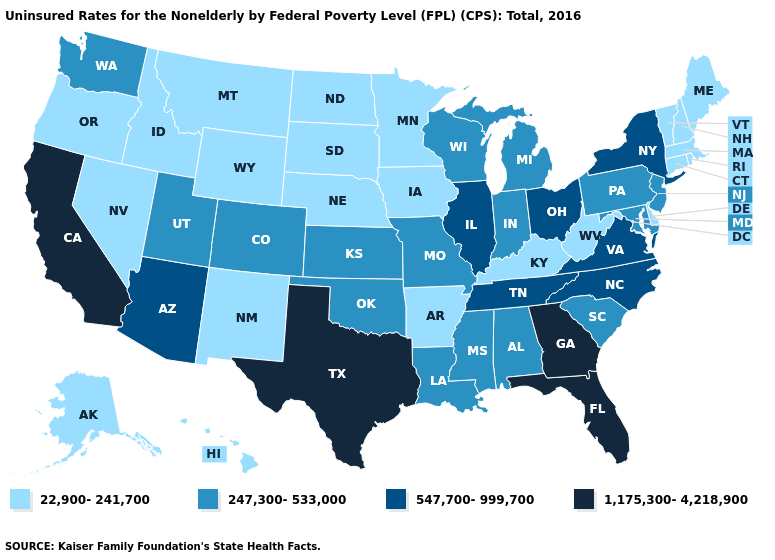Does Colorado have the lowest value in the USA?
Keep it brief. No. What is the value of Connecticut?
Write a very short answer. 22,900-241,700. What is the value of North Dakota?
Give a very brief answer. 22,900-241,700. What is the value of Pennsylvania?
Short answer required. 247,300-533,000. Name the states that have a value in the range 547,700-999,700?
Quick response, please. Arizona, Illinois, New York, North Carolina, Ohio, Tennessee, Virginia. What is the value of Rhode Island?
Quick response, please. 22,900-241,700. Name the states that have a value in the range 22,900-241,700?
Quick response, please. Alaska, Arkansas, Connecticut, Delaware, Hawaii, Idaho, Iowa, Kentucky, Maine, Massachusetts, Minnesota, Montana, Nebraska, Nevada, New Hampshire, New Mexico, North Dakota, Oregon, Rhode Island, South Dakota, Vermont, West Virginia, Wyoming. What is the lowest value in the USA?
Answer briefly. 22,900-241,700. Which states hav the highest value in the West?
Keep it brief. California. Does the first symbol in the legend represent the smallest category?
Give a very brief answer. Yes. Does Pennsylvania have the lowest value in the USA?
Give a very brief answer. No. Which states have the lowest value in the USA?
Short answer required. Alaska, Arkansas, Connecticut, Delaware, Hawaii, Idaho, Iowa, Kentucky, Maine, Massachusetts, Minnesota, Montana, Nebraska, Nevada, New Hampshire, New Mexico, North Dakota, Oregon, Rhode Island, South Dakota, Vermont, West Virginia, Wyoming. Name the states that have a value in the range 22,900-241,700?
Answer briefly. Alaska, Arkansas, Connecticut, Delaware, Hawaii, Idaho, Iowa, Kentucky, Maine, Massachusetts, Minnesota, Montana, Nebraska, Nevada, New Hampshire, New Mexico, North Dakota, Oregon, Rhode Island, South Dakota, Vermont, West Virginia, Wyoming. Name the states that have a value in the range 22,900-241,700?
Write a very short answer. Alaska, Arkansas, Connecticut, Delaware, Hawaii, Idaho, Iowa, Kentucky, Maine, Massachusetts, Minnesota, Montana, Nebraska, Nevada, New Hampshire, New Mexico, North Dakota, Oregon, Rhode Island, South Dakota, Vermont, West Virginia, Wyoming. Name the states that have a value in the range 1,175,300-4,218,900?
Answer briefly. California, Florida, Georgia, Texas. 